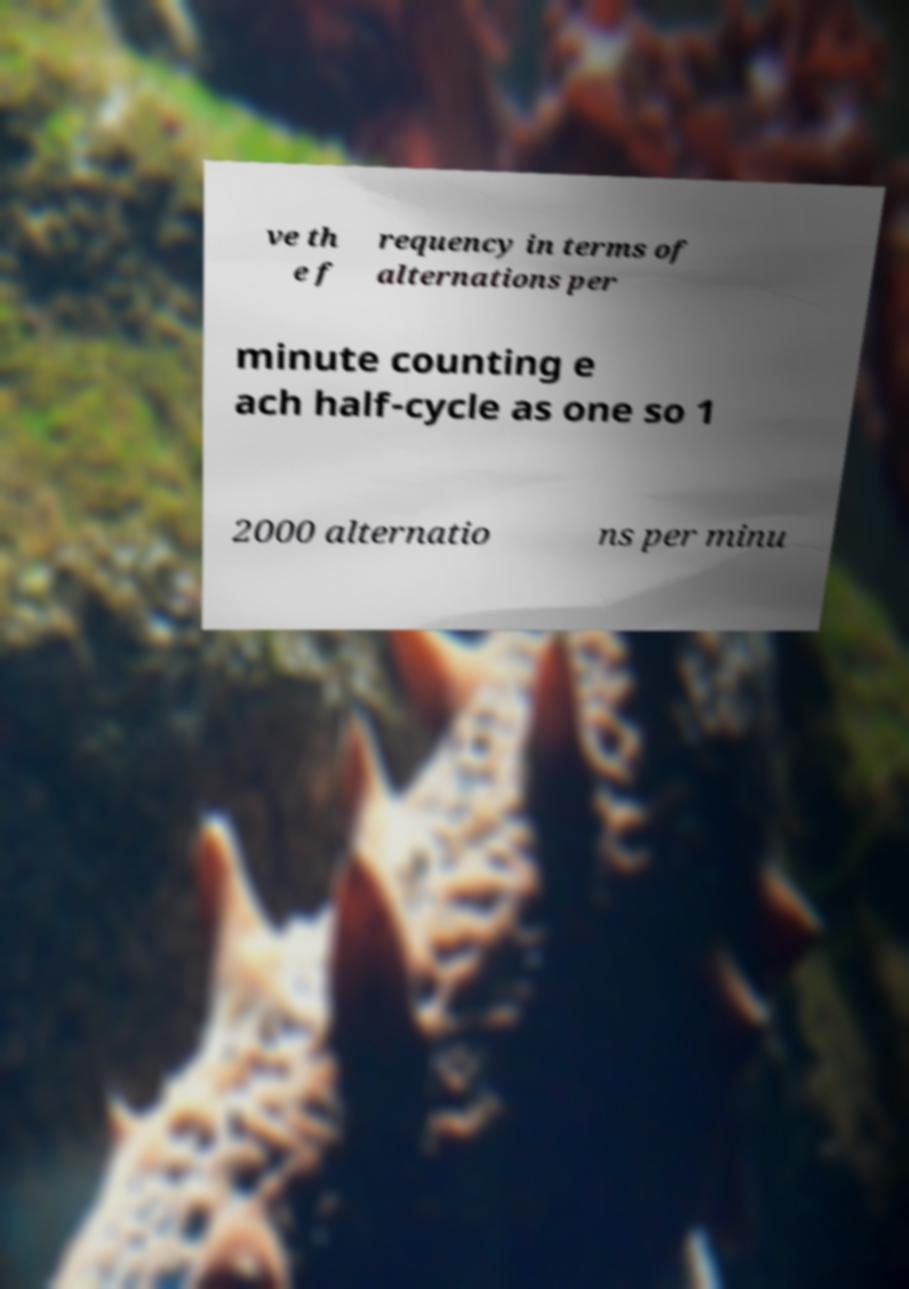There's text embedded in this image that I need extracted. Can you transcribe it verbatim? ve th e f requency in terms of alternations per minute counting e ach half-cycle as one so 1 2000 alternatio ns per minu 